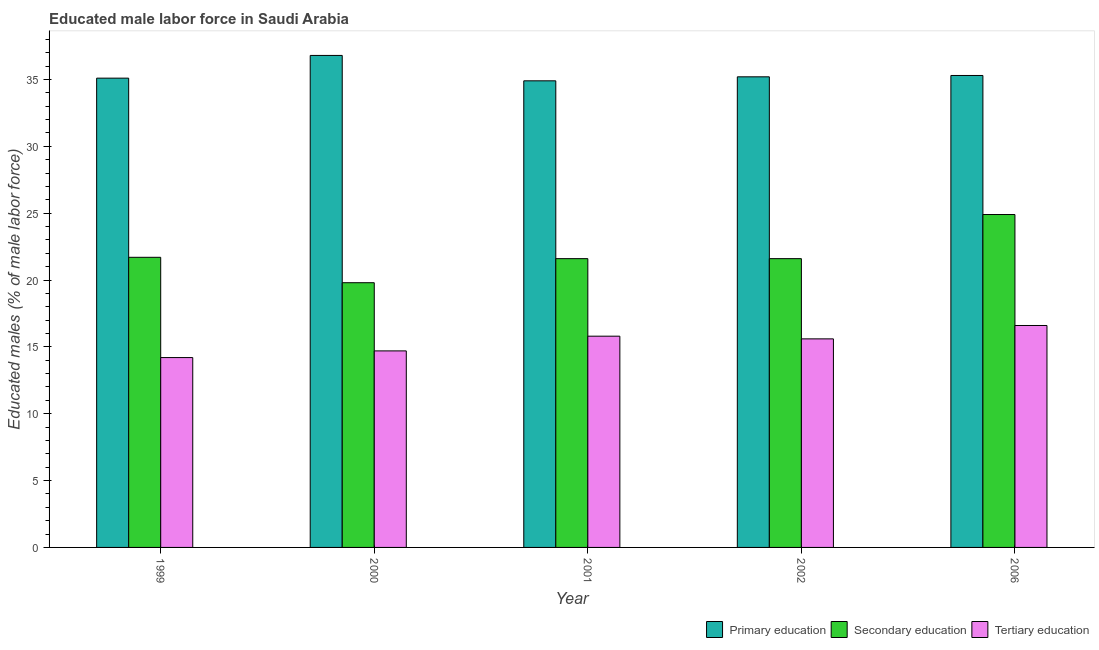Are the number of bars per tick equal to the number of legend labels?
Provide a short and direct response. Yes. In how many cases, is the number of bars for a given year not equal to the number of legend labels?
Keep it short and to the point. 0. What is the percentage of male labor force who received tertiary education in 1999?
Provide a succinct answer. 14.2. Across all years, what is the maximum percentage of male labor force who received primary education?
Provide a succinct answer. 36.8. Across all years, what is the minimum percentage of male labor force who received primary education?
Give a very brief answer. 34.9. In which year was the percentage of male labor force who received tertiary education maximum?
Offer a terse response. 2006. In which year was the percentage of male labor force who received primary education minimum?
Offer a terse response. 2001. What is the total percentage of male labor force who received primary education in the graph?
Your answer should be very brief. 177.3. What is the difference between the percentage of male labor force who received primary education in 1999 and that in 2001?
Your answer should be very brief. 0.2. What is the difference between the percentage of male labor force who received tertiary education in 2000 and the percentage of male labor force who received primary education in 2002?
Give a very brief answer. -0.9. What is the average percentage of male labor force who received tertiary education per year?
Keep it short and to the point. 15.38. What is the ratio of the percentage of male labor force who received tertiary education in 2000 to that in 2006?
Ensure brevity in your answer.  0.89. Is the percentage of male labor force who received secondary education in 1999 less than that in 2000?
Your answer should be compact. No. Is the difference between the percentage of male labor force who received primary education in 2001 and 2006 greater than the difference between the percentage of male labor force who received tertiary education in 2001 and 2006?
Provide a short and direct response. No. What is the difference between the highest and the second highest percentage of male labor force who received secondary education?
Provide a succinct answer. 3.2. What is the difference between the highest and the lowest percentage of male labor force who received tertiary education?
Keep it short and to the point. 2.4. In how many years, is the percentage of male labor force who received tertiary education greater than the average percentage of male labor force who received tertiary education taken over all years?
Offer a very short reply. 3. Is the sum of the percentage of male labor force who received primary education in 1999 and 2001 greater than the maximum percentage of male labor force who received tertiary education across all years?
Your answer should be very brief. Yes. What does the 2nd bar from the left in 2001 represents?
Offer a very short reply. Secondary education. Does the graph contain any zero values?
Keep it short and to the point. No. Does the graph contain grids?
Your response must be concise. No. How many legend labels are there?
Your answer should be compact. 3. How are the legend labels stacked?
Provide a short and direct response. Horizontal. What is the title of the graph?
Offer a terse response. Educated male labor force in Saudi Arabia. What is the label or title of the Y-axis?
Offer a terse response. Educated males (% of male labor force). What is the Educated males (% of male labor force) of Primary education in 1999?
Provide a succinct answer. 35.1. What is the Educated males (% of male labor force) of Secondary education in 1999?
Provide a short and direct response. 21.7. What is the Educated males (% of male labor force) of Tertiary education in 1999?
Your answer should be very brief. 14.2. What is the Educated males (% of male labor force) of Primary education in 2000?
Offer a terse response. 36.8. What is the Educated males (% of male labor force) in Secondary education in 2000?
Provide a short and direct response. 19.8. What is the Educated males (% of male labor force) in Tertiary education in 2000?
Your answer should be very brief. 14.7. What is the Educated males (% of male labor force) of Primary education in 2001?
Provide a succinct answer. 34.9. What is the Educated males (% of male labor force) in Secondary education in 2001?
Your answer should be very brief. 21.6. What is the Educated males (% of male labor force) of Tertiary education in 2001?
Make the answer very short. 15.8. What is the Educated males (% of male labor force) of Primary education in 2002?
Your answer should be very brief. 35.2. What is the Educated males (% of male labor force) in Secondary education in 2002?
Ensure brevity in your answer.  21.6. What is the Educated males (% of male labor force) of Tertiary education in 2002?
Offer a terse response. 15.6. What is the Educated males (% of male labor force) in Primary education in 2006?
Your answer should be compact. 35.3. What is the Educated males (% of male labor force) of Secondary education in 2006?
Offer a very short reply. 24.9. What is the Educated males (% of male labor force) of Tertiary education in 2006?
Offer a terse response. 16.6. Across all years, what is the maximum Educated males (% of male labor force) in Primary education?
Offer a terse response. 36.8. Across all years, what is the maximum Educated males (% of male labor force) in Secondary education?
Make the answer very short. 24.9. Across all years, what is the maximum Educated males (% of male labor force) of Tertiary education?
Keep it short and to the point. 16.6. Across all years, what is the minimum Educated males (% of male labor force) of Primary education?
Your answer should be compact. 34.9. Across all years, what is the minimum Educated males (% of male labor force) of Secondary education?
Offer a very short reply. 19.8. Across all years, what is the minimum Educated males (% of male labor force) of Tertiary education?
Provide a short and direct response. 14.2. What is the total Educated males (% of male labor force) in Primary education in the graph?
Keep it short and to the point. 177.3. What is the total Educated males (% of male labor force) of Secondary education in the graph?
Offer a terse response. 109.6. What is the total Educated males (% of male labor force) of Tertiary education in the graph?
Give a very brief answer. 76.9. What is the difference between the Educated males (% of male labor force) in Secondary education in 1999 and that in 2000?
Keep it short and to the point. 1.9. What is the difference between the Educated males (% of male labor force) in Primary education in 1999 and that in 2001?
Your answer should be compact. 0.2. What is the difference between the Educated males (% of male labor force) in Secondary education in 1999 and that in 2001?
Your response must be concise. 0.1. What is the difference between the Educated males (% of male labor force) in Tertiary education in 1999 and that in 2001?
Your response must be concise. -1.6. What is the difference between the Educated males (% of male labor force) in Tertiary education in 1999 and that in 2002?
Make the answer very short. -1.4. What is the difference between the Educated males (% of male labor force) in Primary education in 1999 and that in 2006?
Give a very brief answer. -0.2. What is the difference between the Educated males (% of male labor force) of Secondary education in 1999 and that in 2006?
Give a very brief answer. -3.2. What is the difference between the Educated males (% of male labor force) in Tertiary education in 1999 and that in 2006?
Your answer should be very brief. -2.4. What is the difference between the Educated males (% of male labor force) in Secondary education in 2000 and that in 2001?
Provide a short and direct response. -1.8. What is the difference between the Educated males (% of male labor force) of Primary education in 2000 and that in 2002?
Make the answer very short. 1.6. What is the difference between the Educated males (% of male labor force) of Secondary education in 2000 and that in 2002?
Your answer should be very brief. -1.8. What is the difference between the Educated males (% of male labor force) in Primary education in 2000 and that in 2006?
Keep it short and to the point. 1.5. What is the difference between the Educated males (% of male labor force) in Secondary education in 2000 and that in 2006?
Give a very brief answer. -5.1. What is the difference between the Educated males (% of male labor force) of Tertiary education in 2000 and that in 2006?
Make the answer very short. -1.9. What is the difference between the Educated males (% of male labor force) in Tertiary education in 2001 and that in 2002?
Offer a terse response. 0.2. What is the difference between the Educated males (% of male labor force) of Primary education in 2001 and that in 2006?
Keep it short and to the point. -0.4. What is the difference between the Educated males (% of male labor force) of Secondary education in 2001 and that in 2006?
Your answer should be compact. -3.3. What is the difference between the Educated males (% of male labor force) of Tertiary education in 2001 and that in 2006?
Give a very brief answer. -0.8. What is the difference between the Educated males (% of male labor force) of Secondary education in 2002 and that in 2006?
Offer a terse response. -3.3. What is the difference between the Educated males (% of male labor force) in Tertiary education in 2002 and that in 2006?
Keep it short and to the point. -1. What is the difference between the Educated males (% of male labor force) in Primary education in 1999 and the Educated males (% of male labor force) in Secondary education in 2000?
Your answer should be compact. 15.3. What is the difference between the Educated males (% of male labor force) of Primary education in 1999 and the Educated males (% of male labor force) of Tertiary education in 2000?
Ensure brevity in your answer.  20.4. What is the difference between the Educated males (% of male labor force) in Secondary education in 1999 and the Educated males (% of male labor force) in Tertiary education in 2000?
Your answer should be compact. 7. What is the difference between the Educated males (% of male labor force) in Primary education in 1999 and the Educated males (% of male labor force) in Tertiary education in 2001?
Your answer should be very brief. 19.3. What is the difference between the Educated males (% of male labor force) in Primary education in 1999 and the Educated males (% of male labor force) in Secondary education in 2002?
Your answer should be very brief. 13.5. What is the difference between the Educated males (% of male labor force) of Secondary education in 1999 and the Educated males (% of male labor force) of Tertiary education in 2002?
Provide a short and direct response. 6.1. What is the difference between the Educated males (% of male labor force) of Primary education in 1999 and the Educated males (% of male labor force) of Secondary education in 2006?
Your answer should be compact. 10.2. What is the difference between the Educated males (% of male labor force) of Primary education in 1999 and the Educated males (% of male labor force) of Tertiary education in 2006?
Give a very brief answer. 18.5. What is the difference between the Educated males (% of male labor force) of Primary education in 2000 and the Educated males (% of male labor force) of Secondary education in 2002?
Your response must be concise. 15.2. What is the difference between the Educated males (% of male labor force) of Primary education in 2000 and the Educated males (% of male labor force) of Tertiary education in 2002?
Your answer should be very brief. 21.2. What is the difference between the Educated males (% of male labor force) of Secondary education in 2000 and the Educated males (% of male labor force) of Tertiary education in 2002?
Ensure brevity in your answer.  4.2. What is the difference between the Educated males (% of male labor force) in Primary education in 2000 and the Educated males (% of male labor force) in Tertiary education in 2006?
Ensure brevity in your answer.  20.2. What is the difference between the Educated males (% of male labor force) of Primary education in 2001 and the Educated males (% of male labor force) of Tertiary education in 2002?
Give a very brief answer. 19.3. What is the difference between the Educated males (% of male labor force) of Secondary education in 2001 and the Educated males (% of male labor force) of Tertiary education in 2002?
Ensure brevity in your answer.  6. What is the difference between the Educated males (% of male labor force) in Secondary education in 2001 and the Educated males (% of male labor force) in Tertiary education in 2006?
Your response must be concise. 5. What is the difference between the Educated males (% of male labor force) in Secondary education in 2002 and the Educated males (% of male labor force) in Tertiary education in 2006?
Ensure brevity in your answer.  5. What is the average Educated males (% of male labor force) in Primary education per year?
Your answer should be very brief. 35.46. What is the average Educated males (% of male labor force) in Secondary education per year?
Offer a terse response. 21.92. What is the average Educated males (% of male labor force) of Tertiary education per year?
Offer a terse response. 15.38. In the year 1999, what is the difference between the Educated males (% of male labor force) in Primary education and Educated males (% of male labor force) in Secondary education?
Offer a terse response. 13.4. In the year 1999, what is the difference between the Educated males (% of male labor force) in Primary education and Educated males (% of male labor force) in Tertiary education?
Your response must be concise. 20.9. In the year 2000, what is the difference between the Educated males (% of male labor force) in Primary education and Educated males (% of male labor force) in Tertiary education?
Offer a very short reply. 22.1. In the year 2001, what is the difference between the Educated males (% of male labor force) in Primary education and Educated males (% of male labor force) in Tertiary education?
Offer a very short reply. 19.1. In the year 2001, what is the difference between the Educated males (% of male labor force) of Secondary education and Educated males (% of male labor force) of Tertiary education?
Your answer should be compact. 5.8. In the year 2002, what is the difference between the Educated males (% of male labor force) in Primary education and Educated males (% of male labor force) in Secondary education?
Offer a very short reply. 13.6. In the year 2002, what is the difference between the Educated males (% of male labor force) in Primary education and Educated males (% of male labor force) in Tertiary education?
Keep it short and to the point. 19.6. In the year 2006, what is the difference between the Educated males (% of male labor force) of Primary education and Educated males (% of male labor force) of Tertiary education?
Your answer should be very brief. 18.7. In the year 2006, what is the difference between the Educated males (% of male labor force) in Secondary education and Educated males (% of male labor force) in Tertiary education?
Your response must be concise. 8.3. What is the ratio of the Educated males (% of male labor force) of Primary education in 1999 to that in 2000?
Make the answer very short. 0.95. What is the ratio of the Educated males (% of male labor force) in Secondary education in 1999 to that in 2000?
Your response must be concise. 1.1. What is the ratio of the Educated males (% of male labor force) in Tertiary education in 1999 to that in 2000?
Keep it short and to the point. 0.97. What is the ratio of the Educated males (% of male labor force) in Primary education in 1999 to that in 2001?
Your answer should be very brief. 1.01. What is the ratio of the Educated males (% of male labor force) in Secondary education in 1999 to that in 2001?
Your response must be concise. 1. What is the ratio of the Educated males (% of male labor force) of Tertiary education in 1999 to that in 2001?
Your response must be concise. 0.9. What is the ratio of the Educated males (% of male labor force) in Primary education in 1999 to that in 2002?
Offer a terse response. 1. What is the ratio of the Educated males (% of male labor force) in Tertiary education in 1999 to that in 2002?
Offer a terse response. 0.91. What is the ratio of the Educated males (% of male labor force) in Secondary education in 1999 to that in 2006?
Offer a very short reply. 0.87. What is the ratio of the Educated males (% of male labor force) in Tertiary education in 1999 to that in 2006?
Your response must be concise. 0.86. What is the ratio of the Educated males (% of male labor force) in Primary education in 2000 to that in 2001?
Make the answer very short. 1.05. What is the ratio of the Educated males (% of male labor force) of Secondary education in 2000 to that in 2001?
Ensure brevity in your answer.  0.92. What is the ratio of the Educated males (% of male labor force) of Tertiary education in 2000 to that in 2001?
Your response must be concise. 0.93. What is the ratio of the Educated males (% of male labor force) of Primary education in 2000 to that in 2002?
Your answer should be very brief. 1.05. What is the ratio of the Educated males (% of male labor force) of Tertiary education in 2000 to that in 2002?
Your response must be concise. 0.94. What is the ratio of the Educated males (% of male labor force) of Primary education in 2000 to that in 2006?
Your response must be concise. 1.04. What is the ratio of the Educated males (% of male labor force) of Secondary education in 2000 to that in 2006?
Offer a very short reply. 0.8. What is the ratio of the Educated males (% of male labor force) of Tertiary education in 2000 to that in 2006?
Your answer should be very brief. 0.89. What is the ratio of the Educated males (% of male labor force) of Primary education in 2001 to that in 2002?
Your response must be concise. 0.99. What is the ratio of the Educated males (% of male labor force) of Secondary education in 2001 to that in 2002?
Provide a short and direct response. 1. What is the ratio of the Educated males (% of male labor force) in Tertiary education in 2001 to that in 2002?
Offer a terse response. 1.01. What is the ratio of the Educated males (% of male labor force) of Primary education in 2001 to that in 2006?
Provide a short and direct response. 0.99. What is the ratio of the Educated males (% of male labor force) in Secondary education in 2001 to that in 2006?
Ensure brevity in your answer.  0.87. What is the ratio of the Educated males (% of male labor force) in Tertiary education in 2001 to that in 2006?
Give a very brief answer. 0.95. What is the ratio of the Educated males (% of male labor force) of Primary education in 2002 to that in 2006?
Keep it short and to the point. 1. What is the ratio of the Educated males (% of male labor force) of Secondary education in 2002 to that in 2006?
Offer a terse response. 0.87. What is the ratio of the Educated males (% of male labor force) in Tertiary education in 2002 to that in 2006?
Provide a succinct answer. 0.94. What is the difference between the highest and the second highest Educated males (% of male labor force) in Secondary education?
Keep it short and to the point. 3.2. What is the difference between the highest and the lowest Educated males (% of male labor force) in Primary education?
Offer a very short reply. 1.9. 